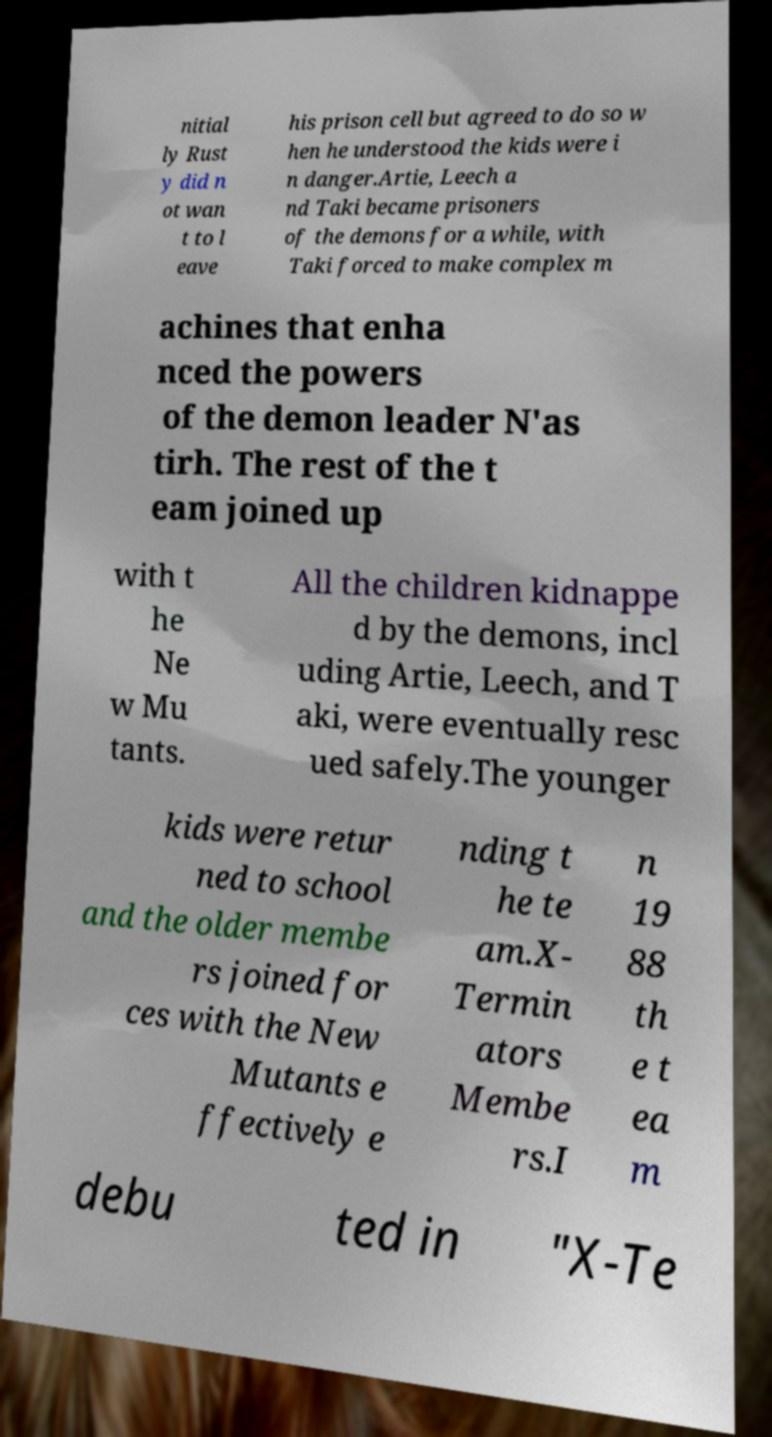What messages or text are displayed in this image? I need them in a readable, typed format. nitial ly Rust y did n ot wan t to l eave his prison cell but agreed to do so w hen he understood the kids were i n danger.Artie, Leech a nd Taki became prisoners of the demons for a while, with Taki forced to make complex m achines that enha nced the powers of the demon leader N'as tirh. The rest of the t eam joined up with t he Ne w Mu tants. All the children kidnappe d by the demons, incl uding Artie, Leech, and T aki, were eventually resc ued safely.The younger kids were retur ned to school and the older membe rs joined for ces with the New Mutants e ffectively e nding t he te am.X- Termin ators Membe rs.I n 19 88 th e t ea m debu ted in "X-Te 